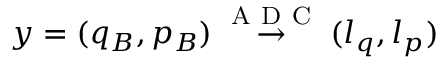Convert formula to latex. <formula><loc_0><loc_0><loc_500><loc_500>y = ( q _ { B } , p _ { B } ) \overset { A D C } { \rightarrow } ( l _ { q } , l _ { p } )</formula> 